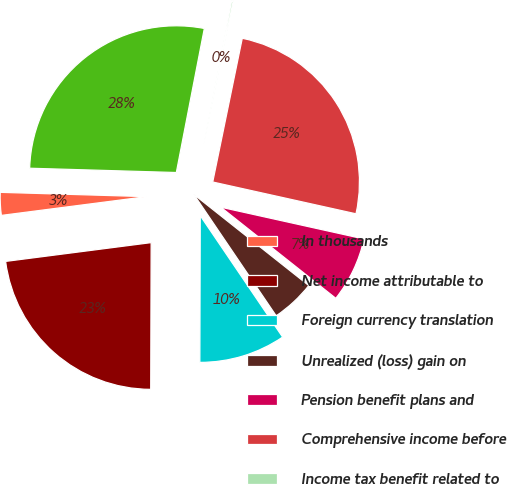<chart> <loc_0><loc_0><loc_500><loc_500><pie_chart><fcel>In thousands<fcel>Net income attributable to<fcel>Foreign currency translation<fcel>Unrealized (loss) gain on<fcel>Pension benefit plans and<fcel>Comprehensive income before<fcel>Income tax benefit related to<fcel>Comprehensive income<nl><fcel>2.51%<fcel>22.91%<fcel>9.53%<fcel>4.85%<fcel>7.19%<fcel>25.25%<fcel>0.17%<fcel>27.59%<nl></chart> 